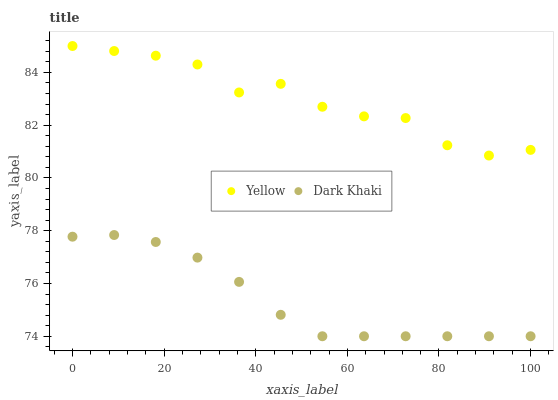Does Dark Khaki have the minimum area under the curve?
Answer yes or no. Yes. Does Yellow have the maximum area under the curve?
Answer yes or no. Yes. Does Yellow have the minimum area under the curve?
Answer yes or no. No. Is Dark Khaki the smoothest?
Answer yes or no. Yes. Is Yellow the roughest?
Answer yes or no. Yes. Is Yellow the smoothest?
Answer yes or no. No. Does Dark Khaki have the lowest value?
Answer yes or no. Yes. Does Yellow have the lowest value?
Answer yes or no. No. Does Yellow have the highest value?
Answer yes or no. Yes. Is Dark Khaki less than Yellow?
Answer yes or no. Yes. Is Yellow greater than Dark Khaki?
Answer yes or no. Yes. Does Dark Khaki intersect Yellow?
Answer yes or no. No. 